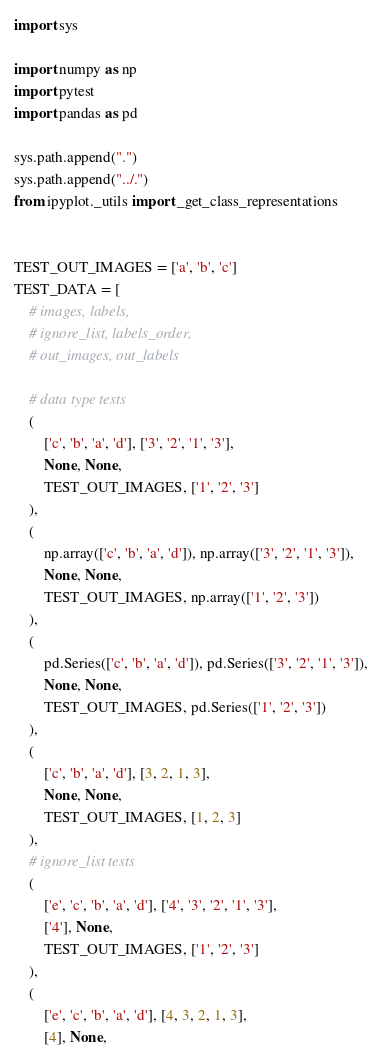<code> <loc_0><loc_0><loc_500><loc_500><_Python_>import sys

import numpy as np
import pytest
import pandas as pd

sys.path.append(".")
sys.path.append("../.")
from ipyplot._utils import _get_class_representations


TEST_OUT_IMAGES = ['a', 'b', 'c']
TEST_DATA = [
    # images, labels,
    # ignore_list, labels_order,
    # out_images, out_labels

    # data type tests
    (
        ['c', 'b', 'a', 'd'], ['3', '2', '1', '3'],
        None, None,
        TEST_OUT_IMAGES, ['1', '2', '3']
    ),
    (
        np.array(['c', 'b', 'a', 'd']), np.array(['3', '2', '1', '3']),
        None, None,
        TEST_OUT_IMAGES, np.array(['1', '2', '3'])
    ),
    (
        pd.Series(['c', 'b', 'a', 'd']), pd.Series(['3', '2', '1', '3']),
        None, None,
        TEST_OUT_IMAGES, pd.Series(['1', '2', '3'])
    ),
    (
        ['c', 'b', 'a', 'd'], [3, 2, 1, 3],
        None, None,
        TEST_OUT_IMAGES, [1, 2, 3]
    ),
    # ignore_list tests
    (
        ['e', 'c', 'b', 'a', 'd'], ['4', '3', '2', '1', '3'],
        ['4'], None,
        TEST_OUT_IMAGES, ['1', '2', '3']
    ),
    (
        ['e', 'c', 'b', 'a', 'd'], [4, 3, 2, 1, 3],
        [4], None,</code> 